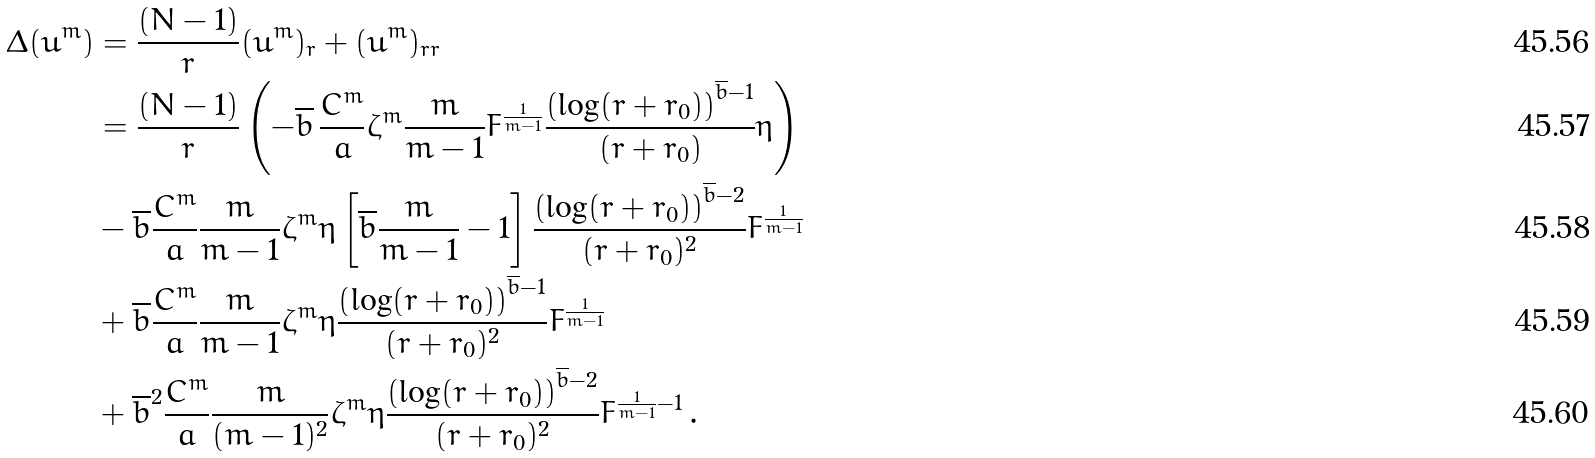<formula> <loc_0><loc_0><loc_500><loc_500>\Delta ( \bar { u } ^ { m } ) & = \frac { ( N - 1 ) } { r } ( \bar { u } ^ { m } ) _ { r } + ( \bar { u } ^ { m } ) _ { r r } \\ & = \frac { ( N - 1 ) } { r } \left ( - \overline { b } \, \frac { C ^ { m } } { a } \zeta ^ { m } \frac { m } { m - 1 } F ^ { \frac { 1 } { m - 1 } } \frac { \left ( \log ( r + r _ { 0 } ) \right ) ^ { \overline { b } - 1 } } { ( r + r _ { 0 } ) } \eta \right ) \\ & - \overline { b } \frac { C ^ { m } } { a } \frac { m } { m - 1 } \zeta ^ { m } \eta \left [ \overline { b } \frac { m } { m - 1 } - 1 \right ] \frac { \left ( \log ( r + r _ { 0 } ) \right ) ^ { \overline { b } - 2 } } { ( r + r _ { 0 } ) ^ { 2 } } F ^ { \frac { 1 } { m - 1 } } \\ & + \overline { b } \frac { C ^ { m } } { a } \frac { m } { m - 1 } \zeta ^ { m } \eta \frac { \left ( \log ( r + r _ { 0 } ) \right ) ^ { \overline { b } - 1 } } { ( r + r _ { 0 } ) ^ { 2 } } F ^ { \frac { 1 } { m - 1 } } \\ & + \overline { b } ^ { 2 } \frac { C ^ { m } } { a } \frac { m } { ( m - 1 ) ^ { 2 } } \zeta ^ { m } \eta \frac { \left ( \log ( r + r _ { 0 } ) \right ) ^ { \overline { b } - 2 } } { ( r + r _ { 0 } ) ^ { 2 } } F ^ { \frac { 1 } { m - 1 } - 1 } \, .</formula> 